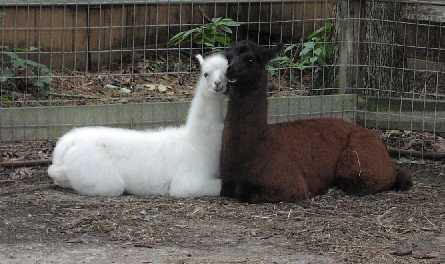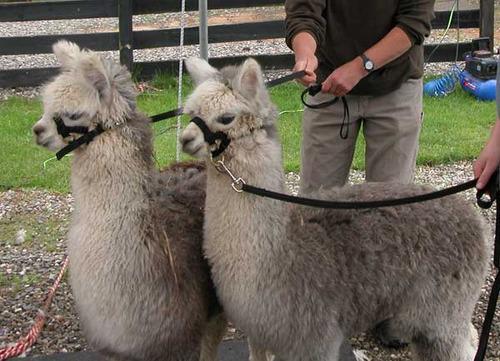The first image is the image on the left, the second image is the image on the right. Examine the images to the left and right. Is the description "In the right image, a baby llama with its body turned left and its head turned right is standing near a standing adult llama." accurate? Answer yes or no. No. The first image is the image on the left, the second image is the image on the right. Assess this claim about the two images: "One of the images show only two llamas that are facing the same direction as the other.". Correct or not? Answer yes or no. Yes. 